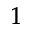<formula> <loc_0><loc_0><loc_500><loc_500>^ { 1 }</formula> 